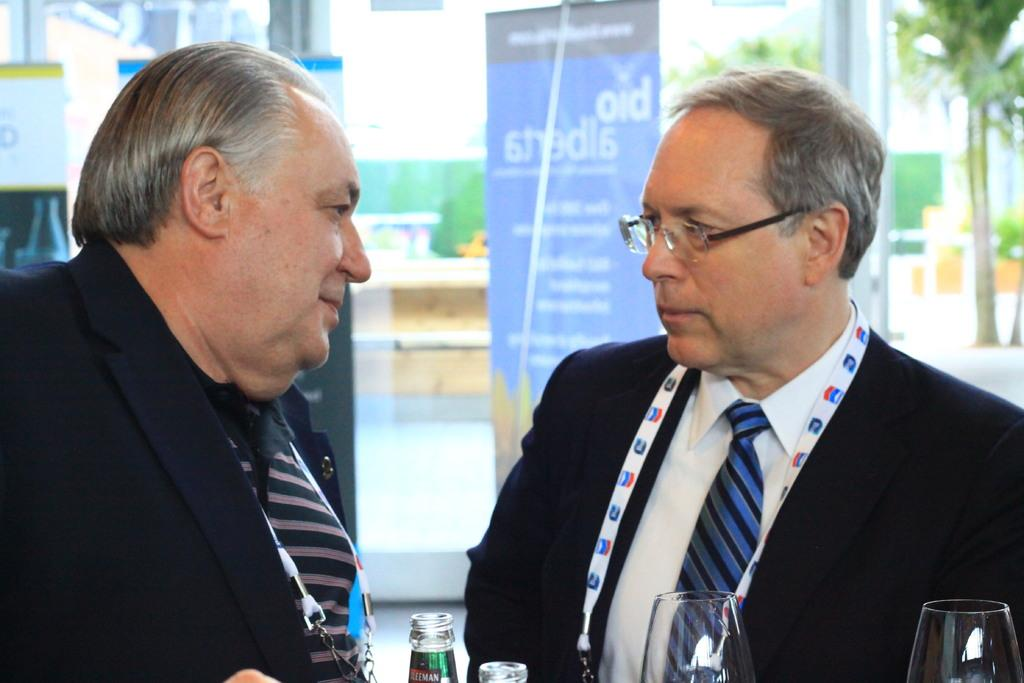How many people are in the image? There are two people in the image. What are the people wearing? The people are wearing different color dresses. What objects can be seen in the image besides the people? There are bottles, glasses, a banner, trees, and other objects in the background. Can you describe the background of the image? The background is blurred and includes trees, a banner, and other objects. What type of tooth is being used as bait in the image? There is no tooth or bait present in the image. Who is the authority figure in the image? There is no authority figure mentioned or depicted in the image. 